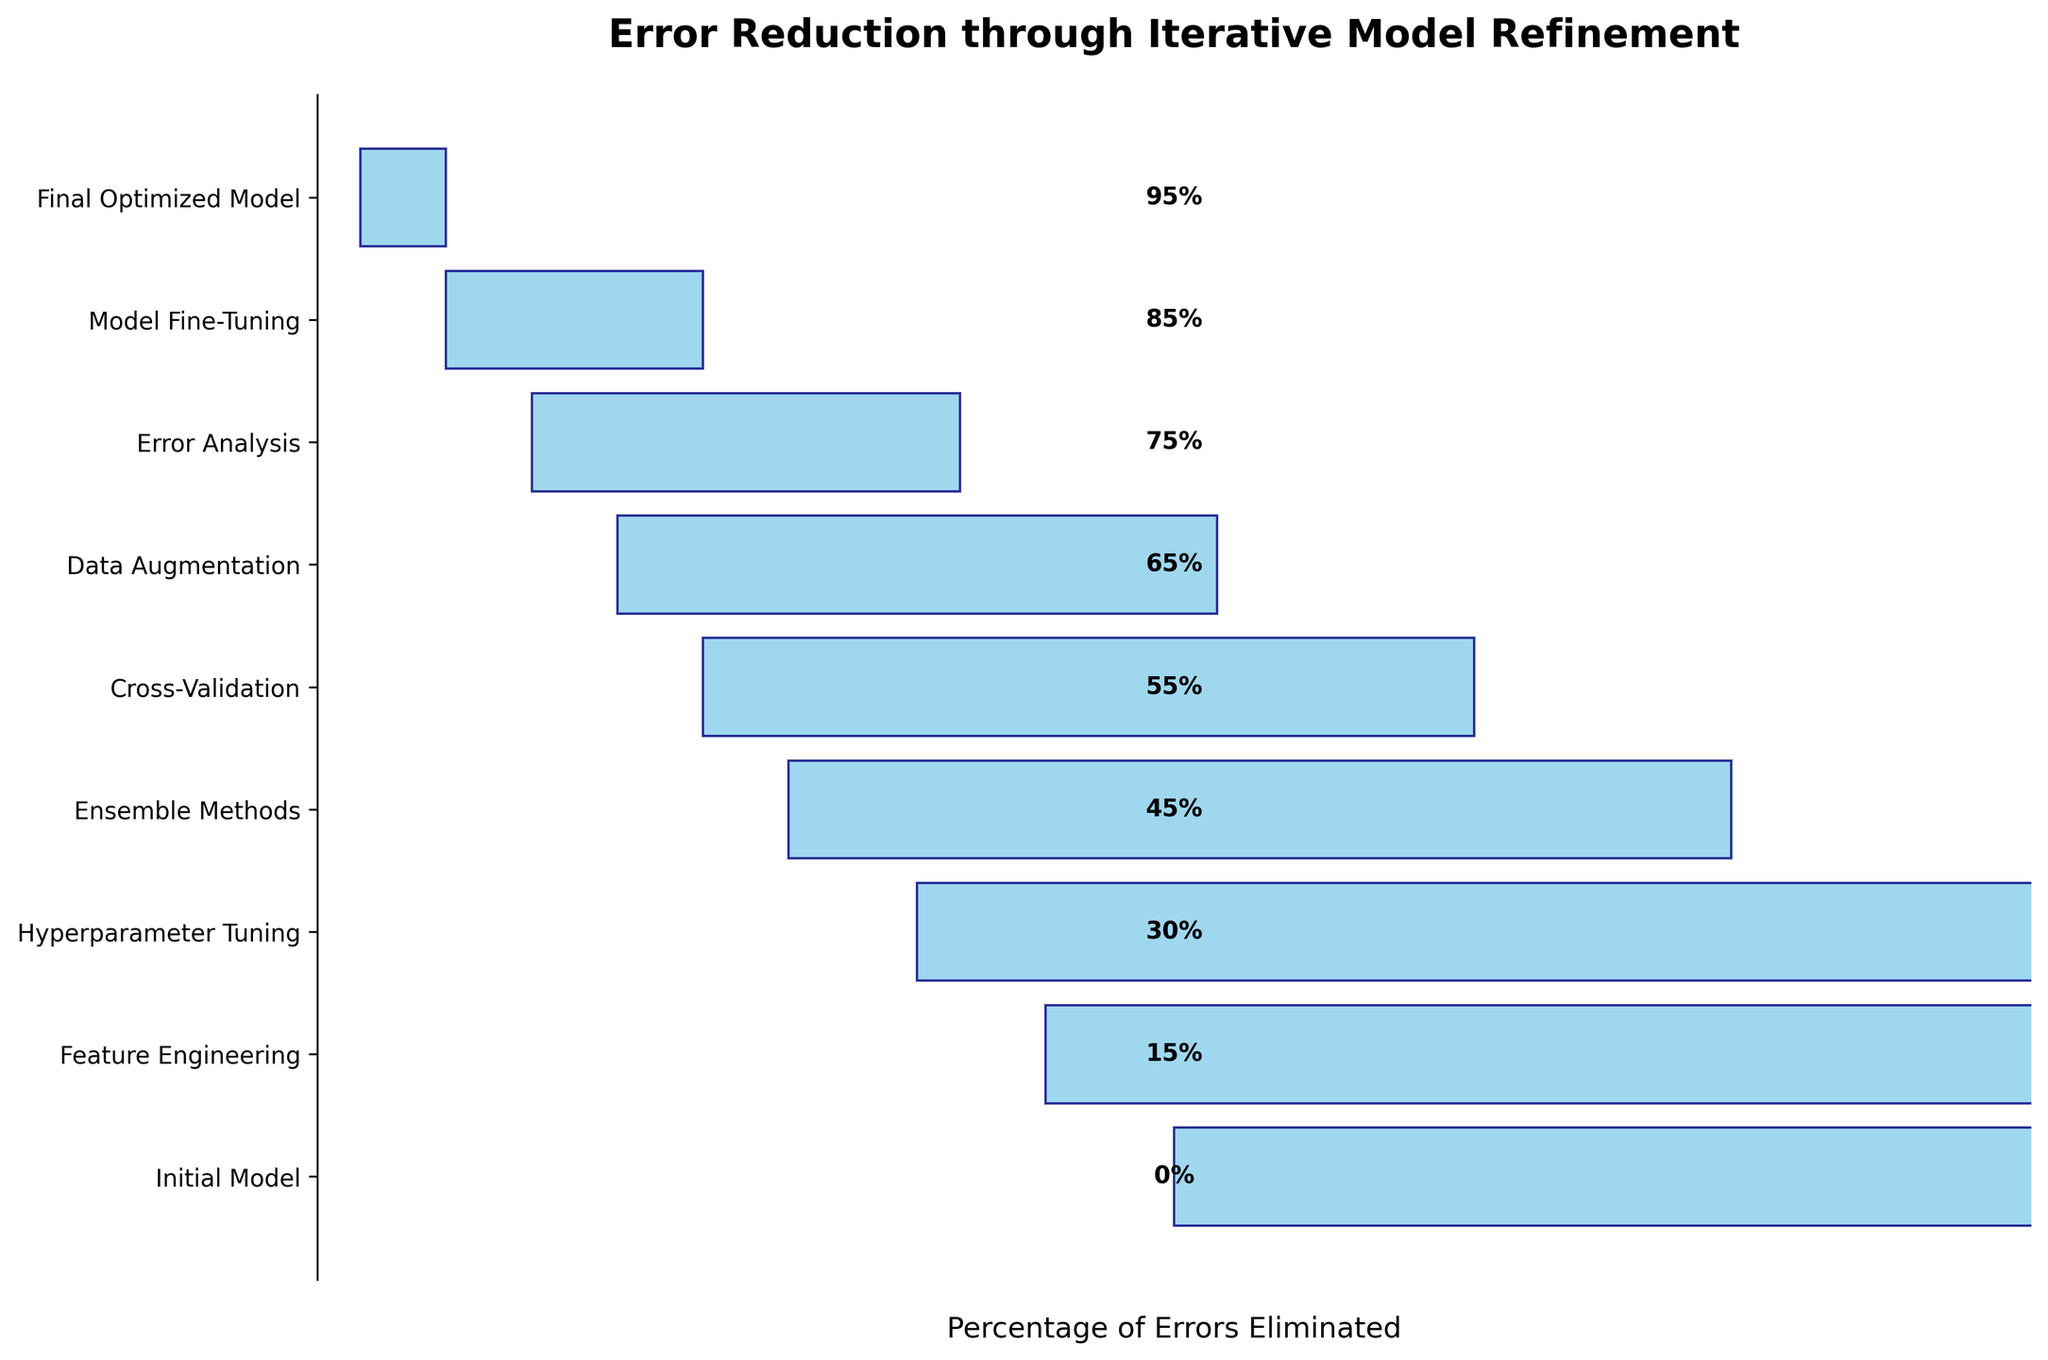What is the title of the figure? The title is prominently displayed at the top of the figure. It reads "Error Reduction through Iterative Model Refinement."
Answer: Error Reduction through Iterative Model Refinement What percentage of errors is eliminated by the initial model? The initial model is the first stage listed. According to the figure, the initial model eliminates 0% of the errors.
Answer: 0% How much percentage of error reduction is achieved by hyperparameter tuning? In the figure, hyperparameter tuning is the third stage listed. It shows that 30% of the errors are eliminated by this stage.
Answer: 30% Which stage achieves the highest percentage of error reduction? By looking at the funnel chart, we can see that the final optimized model, which is the last stage, achieves the highest error reduction at 95%.
Answer: Final Optimized Model What is the difference in the percentage of errors eliminated between data augmentation and model fine-tuning? Data augmentation eliminates 65% of errors and model fine-tuning eliminates 85%. The difference between them is 85% - 65% = 20%.
Answer: 20% How many stages are there in total in the figure? By counting the labels on the y-axis, we can see that there are 9 stages total listed in the funnel chart.
Answer: 9 Which stage sees the least improvement in error reduction after the initial model? Comparing all stages after the initial model, feature engineering shows the smallest improvement, eliminating only 15% of errors.
Answer: Feature Engineering By what percentage does cross-validation improve error reduction over ensemble methods? Cross-validation improves error reduction to 55%, while ensemble methods achieve 45%. The percentage difference is 55% - 45% = 10%.
Answer: 10% At which stage does the error reduction exceed 50%? Referring to the figure, cross-validation is the first stage where the error reduction exceeds 50%, at 55%.
Answer: Cross-Validation How much total error reduction is achieved by the initial model and feature engineering combined? The initial model achieves 0% error reduction and feature engineering achieves 15%. So, the total is 0% + 15% = 15%.
Answer: 15% 